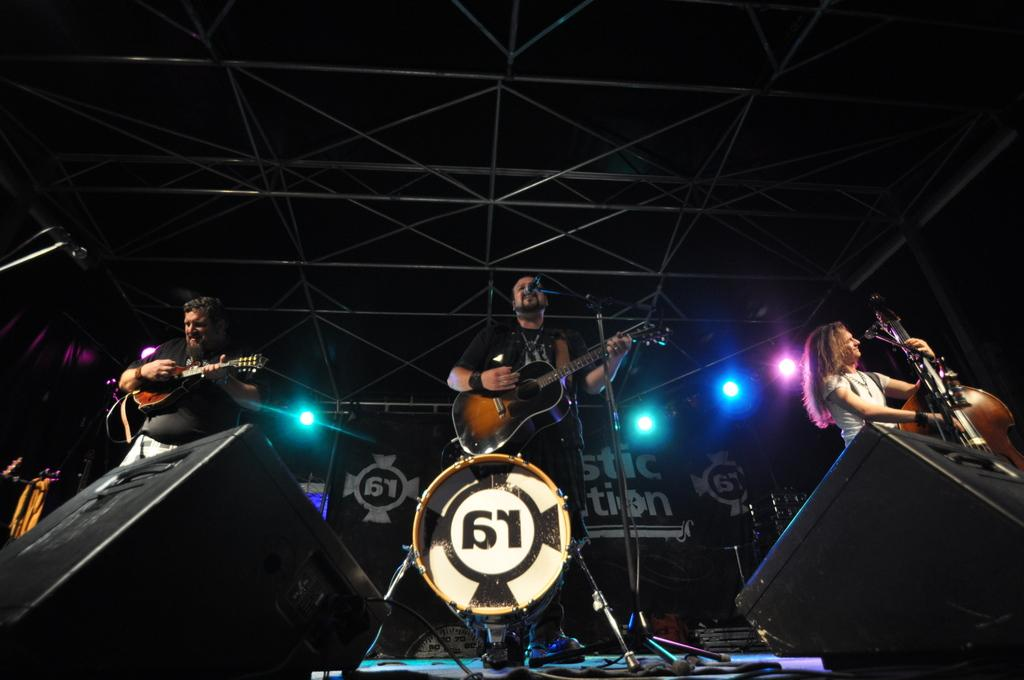What are the people on the stage doing? The people on the stage are playing guitars. What can be seen behind the people on the stage? There are large sound boxes behind the people on the stage. What type of wine is being served on the stage during the performance? There is no wine present in the image; it features people playing guitars on a stage with large sound boxes behind them. 